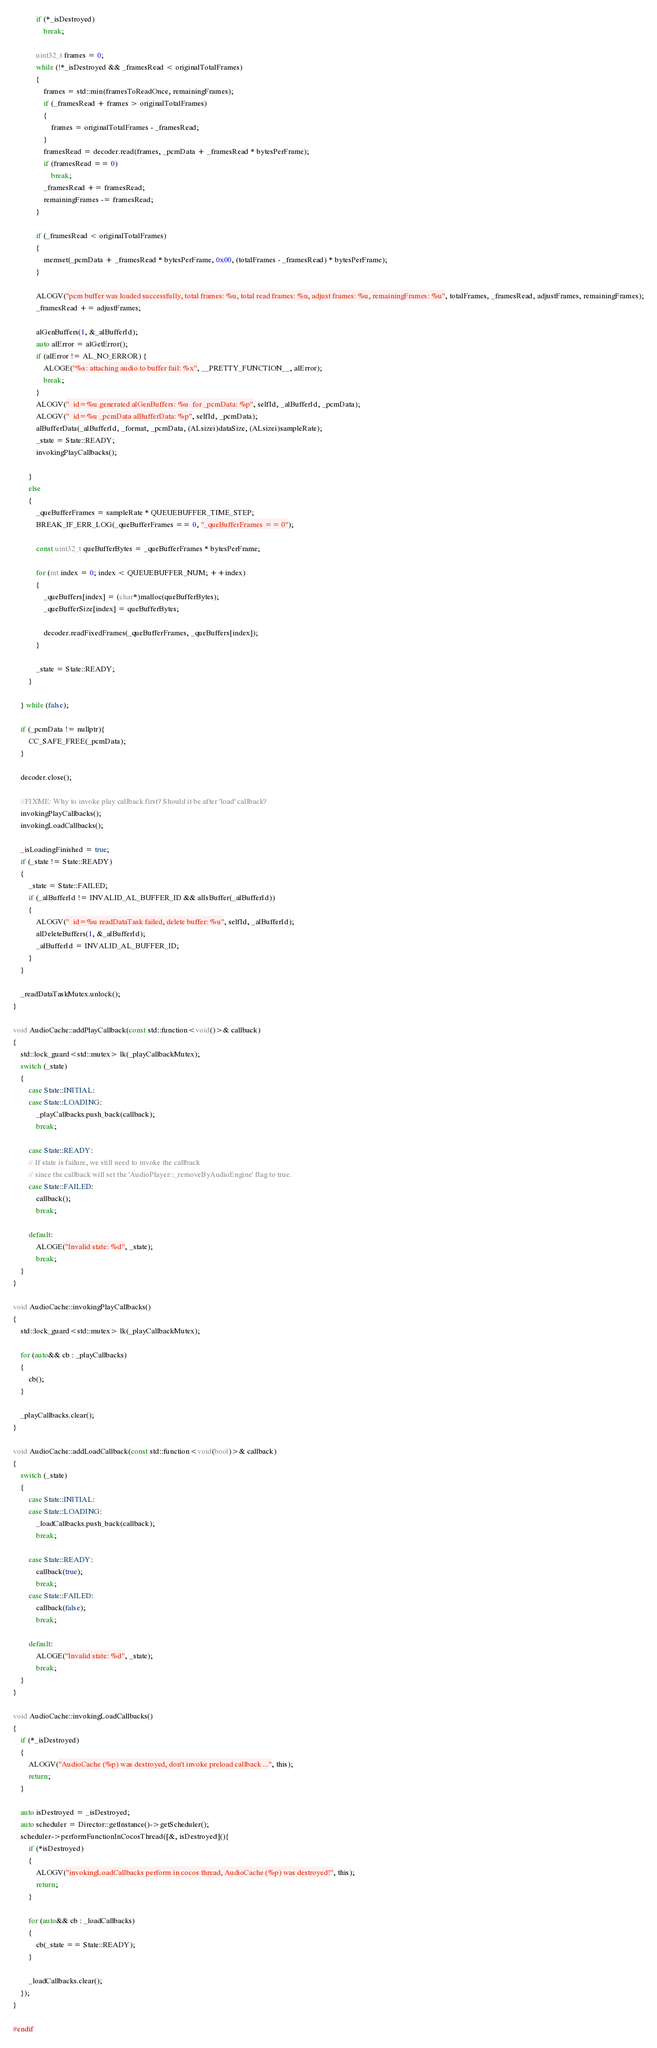<code> <loc_0><loc_0><loc_500><loc_500><_ObjectiveC_>            if (*_isDestroyed)
                break;

            uint32_t frames = 0;
            while (!*_isDestroyed && _framesRead < originalTotalFrames)
            {
                frames = std::min(framesToReadOnce, remainingFrames);
                if (_framesRead + frames > originalTotalFrames)
                {
                    frames = originalTotalFrames - _framesRead;
                }
                framesRead = decoder.read(frames, _pcmData + _framesRead * bytesPerFrame);
                if (framesRead == 0)
                    break;
                _framesRead += framesRead;
                remainingFrames -= framesRead;
            }

            if (_framesRead < originalTotalFrames)
            {
                memset(_pcmData + _framesRead * bytesPerFrame, 0x00, (totalFrames - _framesRead) * bytesPerFrame);
            }

            ALOGV("pcm buffer was loaded successfully, total frames: %u, total read frames: %u, adjust frames: %u, remainingFrames: %u", totalFrames, _framesRead, adjustFrames, remainingFrames);
            _framesRead += adjustFrames;

            alGenBuffers(1, &_alBufferId);
            auto alError = alGetError();
            if (alError != AL_NO_ERROR) {
                ALOGE("%s: attaching audio to buffer fail: %x", __PRETTY_FUNCTION__, alError);
                break;
            }
            ALOGV("  id=%u generated alGenBuffers: %u  for _pcmData: %p", selfId, _alBufferId, _pcmData);
            ALOGV("  id=%u _pcmData alBufferData: %p", selfId, _pcmData);
            alBufferData(_alBufferId, _format, _pcmData, (ALsizei)dataSize, (ALsizei)sampleRate);
            _state = State::READY;
            invokingPlayCallbacks();

        }
        else
        {
            _queBufferFrames = sampleRate * QUEUEBUFFER_TIME_STEP;
            BREAK_IF_ERR_LOG(_queBufferFrames == 0, "_queBufferFrames == 0");

            const uint32_t queBufferBytes = _queBufferFrames * bytesPerFrame;

            for (int index = 0; index < QUEUEBUFFER_NUM; ++index)
            {
                _queBuffers[index] = (char*)malloc(queBufferBytes);
                _queBufferSize[index] = queBufferBytes;

                decoder.readFixedFrames(_queBufferFrames, _queBuffers[index]);
            }

            _state = State::READY;
        }

    } while (false);

    if (_pcmData != nullptr){
        CC_SAFE_FREE(_pcmData);
    }

    decoder.close();

    //FIXME: Why to invoke play callback first? Should it be after 'load' callback?
    invokingPlayCallbacks();
    invokingLoadCallbacks();

    _isLoadingFinished = true;
    if (_state != State::READY)
    {
        _state = State::FAILED;
        if (_alBufferId != INVALID_AL_BUFFER_ID && alIsBuffer(_alBufferId))
        {
            ALOGV("  id=%u readDataTask failed, delete buffer: %u", selfId, _alBufferId);
            alDeleteBuffers(1, &_alBufferId);
            _alBufferId = INVALID_AL_BUFFER_ID;
        }
    }

    _readDataTaskMutex.unlock();
}

void AudioCache::addPlayCallback(const std::function<void()>& callback)
{
    std::lock_guard<std::mutex> lk(_playCallbackMutex);
    switch (_state)
    {
        case State::INITIAL:
        case State::LOADING:
            _playCallbacks.push_back(callback);
            break;

        case State::READY:
        // If state is failure, we still need to invoke the callback
        // since the callback will set the 'AudioPlayer::_removeByAudioEngine' flag to true.
        case State::FAILED:
            callback();
            break;

        default:
            ALOGE("Invalid state: %d", _state);
            break;
    }
}

void AudioCache::invokingPlayCallbacks()
{
    std::lock_guard<std::mutex> lk(_playCallbackMutex);

    for (auto&& cb : _playCallbacks)
    {
        cb();
    }

    _playCallbacks.clear();
}

void AudioCache::addLoadCallback(const std::function<void(bool)>& callback)
{
    switch (_state)
    {
        case State::INITIAL:
        case State::LOADING:
            _loadCallbacks.push_back(callback);
            break;

        case State::READY:
            callback(true);
            break;
        case State::FAILED:
            callback(false);
            break;

        default:
            ALOGE("Invalid state: %d", _state);
            break;
    }
}

void AudioCache::invokingLoadCallbacks()
{
    if (*_isDestroyed)
    {
        ALOGV("AudioCache (%p) was destroyed, don't invoke preload callback ...", this);
        return;
    }

    auto isDestroyed = _isDestroyed;
    auto scheduler = Director::getInstance()->getScheduler();
    scheduler->performFunctionInCocosThread([&, isDestroyed](){
        if (*isDestroyed)
        {
            ALOGV("invokingLoadCallbacks perform in cocos thread, AudioCache (%p) was destroyed!", this);
            return;
        }

        for (auto&& cb : _loadCallbacks)
        {
            cb(_state == State::READY);
        }

        _loadCallbacks.clear();
    });
}

#endif
</code> 